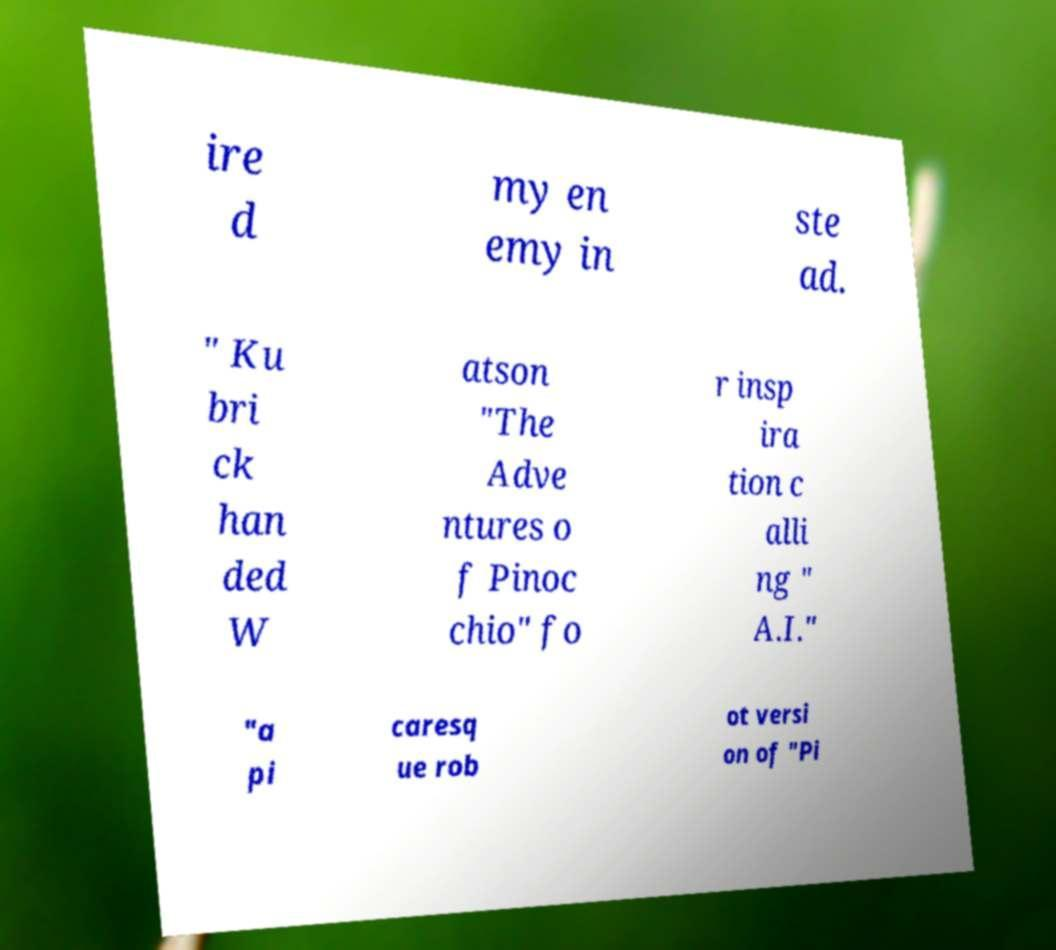Please identify and transcribe the text found in this image. ire d my en emy in ste ad. " Ku bri ck han ded W atson "The Adve ntures o f Pinoc chio" fo r insp ira tion c alli ng " A.I." "a pi caresq ue rob ot versi on of "Pi 